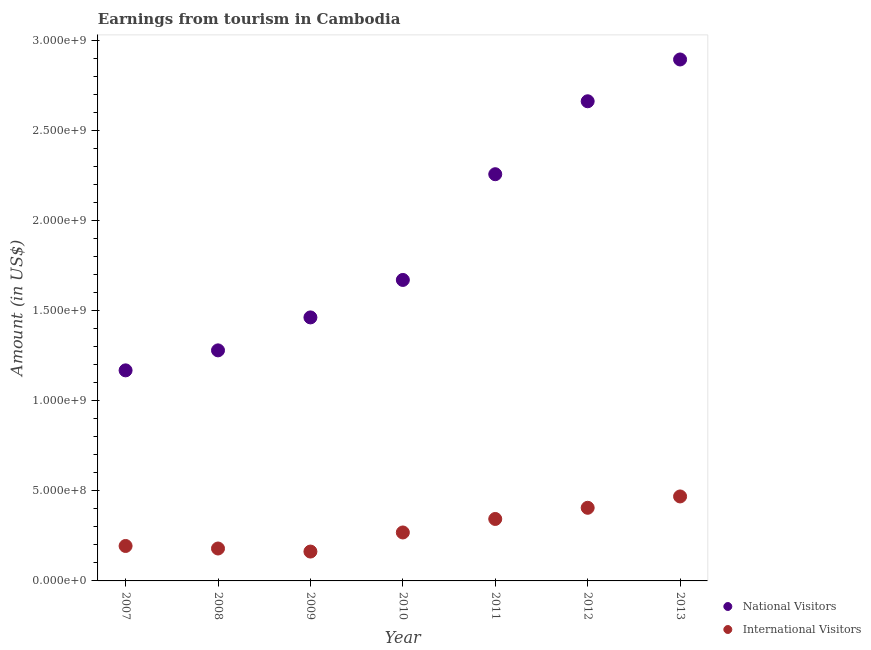How many different coloured dotlines are there?
Your response must be concise. 2. What is the amount earned from international visitors in 2009?
Provide a succinct answer. 1.63e+08. Across all years, what is the maximum amount earned from national visitors?
Give a very brief answer. 2.90e+09. Across all years, what is the minimum amount earned from international visitors?
Provide a succinct answer. 1.63e+08. In which year was the amount earned from international visitors minimum?
Provide a short and direct response. 2009. What is the total amount earned from national visitors in the graph?
Ensure brevity in your answer.  1.34e+1. What is the difference between the amount earned from international visitors in 2007 and that in 2009?
Your answer should be very brief. 3.10e+07. What is the difference between the amount earned from international visitors in 2013 and the amount earned from national visitors in 2009?
Provide a succinct answer. -9.94e+08. What is the average amount earned from international visitors per year?
Keep it short and to the point. 2.89e+08. In the year 2009, what is the difference between the amount earned from international visitors and amount earned from national visitors?
Ensure brevity in your answer.  -1.30e+09. In how many years, is the amount earned from international visitors greater than 2500000000 US$?
Provide a succinct answer. 0. What is the ratio of the amount earned from international visitors in 2009 to that in 2012?
Keep it short and to the point. 0.4. Is the amount earned from national visitors in 2008 less than that in 2009?
Provide a succinct answer. Yes. What is the difference between the highest and the second highest amount earned from international visitors?
Make the answer very short. 6.30e+07. What is the difference between the highest and the lowest amount earned from national visitors?
Your answer should be very brief. 1.73e+09. In how many years, is the amount earned from national visitors greater than the average amount earned from national visitors taken over all years?
Keep it short and to the point. 3. Are the values on the major ticks of Y-axis written in scientific E-notation?
Offer a terse response. Yes. Does the graph contain any zero values?
Give a very brief answer. No. What is the title of the graph?
Your answer should be very brief. Earnings from tourism in Cambodia. Does "Excluding technical cooperation" appear as one of the legend labels in the graph?
Offer a terse response. No. What is the Amount (in US$) of National Visitors in 2007?
Provide a succinct answer. 1.17e+09. What is the Amount (in US$) of International Visitors in 2007?
Your answer should be compact. 1.94e+08. What is the Amount (in US$) in National Visitors in 2008?
Offer a very short reply. 1.28e+09. What is the Amount (in US$) of International Visitors in 2008?
Give a very brief answer. 1.80e+08. What is the Amount (in US$) of National Visitors in 2009?
Your answer should be very brief. 1.46e+09. What is the Amount (in US$) in International Visitors in 2009?
Keep it short and to the point. 1.63e+08. What is the Amount (in US$) of National Visitors in 2010?
Provide a succinct answer. 1.67e+09. What is the Amount (in US$) in International Visitors in 2010?
Make the answer very short. 2.69e+08. What is the Amount (in US$) of National Visitors in 2011?
Offer a terse response. 2.26e+09. What is the Amount (in US$) in International Visitors in 2011?
Offer a very short reply. 3.44e+08. What is the Amount (in US$) in National Visitors in 2012?
Keep it short and to the point. 2.66e+09. What is the Amount (in US$) of International Visitors in 2012?
Give a very brief answer. 4.06e+08. What is the Amount (in US$) in National Visitors in 2013?
Offer a very short reply. 2.90e+09. What is the Amount (in US$) in International Visitors in 2013?
Keep it short and to the point. 4.69e+08. Across all years, what is the maximum Amount (in US$) of National Visitors?
Provide a succinct answer. 2.90e+09. Across all years, what is the maximum Amount (in US$) in International Visitors?
Give a very brief answer. 4.69e+08. Across all years, what is the minimum Amount (in US$) of National Visitors?
Make the answer very short. 1.17e+09. Across all years, what is the minimum Amount (in US$) of International Visitors?
Keep it short and to the point. 1.63e+08. What is the total Amount (in US$) of National Visitors in the graph?
Make the answer very short. 1.34e+1. What is the total Amount (in US$) in International Visitors in the graph?
Ensure brevity in your answer.  2.02e+09. What is the difference between the Amount (in US$) of National Visitors in 2007 and that in 2008?
Provide a succinct answer. -1.11e+08. What is the difference between the Amount (in US$) in International Visitors in 2007 and that in 2008?
Your response must be concise. 1.40e+07. What is the difference between the Amount (in US$) in National Visitors in 2007 and that in 2009?
Give a very brief answer. -2.94e+08. What is the difference between the Amount (in US$) of International Visitors in 2007 and that in 2009?
Provide a short and direct response. 3.10e+07. What is the difference between the Amount (in US$) in National Visitors in 2007 and that in 2010?
Your answer should be compact. -5.02e+08. What is the difference between the Amount (in US$) in International Visitors in 2007 and that in 2010?
Your answer should be very brief. -7.50e+07. What is the difference between the Amount (in US$) in National Visitors in 2007 and that in 2011?
Provide a short and direct response. -1.09e+09. What is the difference between the Amount (in US$) of International Visitors in 2007 and that in 2011?
Offer a terse response. -1.50e+08. What is the difference between the Amount (in US$) in National Visitors in 2007 and that in 2012?
Your answer should be very brief. -1.49e+09. What is the difference between the Amount (in US$) of International Visitors in 2007 and that in 2012?
Provide a succinct answer. -2.12e+08. What is the difference between the Amount (in US$) of National Visitors in 2007 and that in 2013?
Keep it short and to the point. -1.73e+09. What is the difference between the Amount (in US$) in International Visitors in 2007 and that in 2013?
Keep it short and to the point. -2.75e+08. What is the difference between the Amount (in US$) in National Visitors in 2008 and that in 2009?
Your response must be concise. -1.83e+08. What is the difference between the Amount (in US$) in International Visitors in 2008 and that in 2009?
Offer a very short reply. 1.70e+07. What is the difference between the Amount (in US$) of National Visitors in 2008 and that in 2010?
Provide a succinct answer. -3.91e+08. What is the difference between the Amount (in US$) in International Visitors in 2008 and that in 2010?
Offer a very short reply. -8.90e+07. What is the difference between the Amount (in US$) in National Visitors in 2008 and that in 2011?
Keep it short and to the point. -9.78e+08. What is the difference between the Amount (in US$) of International Visitors in 2008 and that in 2011?
Ensure brevity in your answer.  -1.64e+08. What is the difference between the Amount (in US$) in National Visitors in 2008 and that in 2012?
Your answer should be very brief. -1.38e+09. What is the difference between the Amount (in US$) in International Visitors in 2008 and that in 2012?
Offer a terse response. -2.26e+08. What is the difference between the Amount (in US$) in National Visitors in 2008 and that in 2013?
Offer a very short reply. -1.62e+09. What is the difference between the Amount (in US$) in International Visitors in 2008 and that in 2013?
Offer a terse response. -2.89e+08. What is the difference between the Amount (in US$) in National Visitors in 2009 and that in 2010?
Provide a short and direct response. -2.08e+08. What is the difference between the Amount (in US$) in International Visitors in 2009 and that in 2010?
Ensure brevity in your answer.  -1.06e+08. What is the difference between the Amount (in US$) in National Visitors in 2009 and that in 2011?
Provide a short and direct response. -7.95e+08. What is the difference between the Amount (in US$) in International Visitors in 2009 and that in 2011?
Your answer should be very brief. -1.81e+08. What is the difference between the Amount (in US$) in National Visitors in 2009 and that in 2012?
Offer a terse response. -1.20e+09. What is the difference between the Amount (in US$) of International Visitors in 2009 and that in 2012?
Your answer should be compact. -2.43e+08. What is the difference between the Amount (in US$) in National Visitors in 2009 and that in 2013?
Offer a terse response. -1.43e+09. What is the difference between the Amount (in US$) in International Visitors in 2009 and that in 2013?
Provide a succinct answer. -3.06e+08. What is the difference between the Amount (in US$) of National Visitors in 2010 and that in 2011?
Offer a terse response. -5.87e+08. What is the difference between the Amount (in US$) of International Visitors in 2010 and that in 2011?
Provide a short and direct response. -7.50e+07. What is the difference between the Amount (in US$) in National Visitors in 2010 and that in 2012?
Your answer should be compact. -9.92e+08. What is the difference between the Amount (in US$) in International Visitors in 2010 and that in 2012?
Ensure brevity in your answer.  -1.37e+08. What is the difference between the Amount (in US$) in National Visitors in 2010 and that in 2013?
Offer a very short reply. -1.22e+09. What is the difference between the Amount (in US$) in International Visitors in 2010 and that in 2013?
Give a very brief answer. -2.00e+08. What is the difference between the Amount (in US$) of National Visitors in 2011 and that in 2012?
Your answer should be compact. -4.05e+08. What is the difference between the Amount (in US$) of International Visitors in 2011 and that in 2012?
Give a very brief answer. -6.20e+07. What is the difference between the Amount (in US$) of National Visitors in 2011 and that in 2013?
Make the answer very short. -6.37e+08. What is the difference between the Amount (in US$) in International Visitors in 2011 and that in 2013?
Ensure brevity in your answer.  -1.25e+08. What is the difference between the Amount (in US$) in National Visitors in 2012 and that in 2013?
Your answer should be compact. -2.32e+08. What is the difference between the Amount (in US$) of International Visitors in 2012 and that in 2013?
Your answer should be compact. -6.30e+07. What is the difference between the Amount (in US$) of National Visitors in 2007 and the Amount (in US$) of International Visitors in 2008?
Make the answer very short. 9.89e+08. What is the difference between the Amount (in US$) of National Visitors in 2007 and the Amount (in US$) of International Visitors in 2009?
Offer a very short reply. 1.01e+09. What is the difference between the Amount (in US$) in National Visitors in 2007 and the Amount (in US$) in International Visitors in 2010?
Give a very brief answer. 9.00e+08. What is the difference between the Amount (in US$) of National Visitors in 2007 and the Amount (in US$) of International Visitors in 2011?
Your answer should be compact. 8.25e+08. What is the difference between the Amount (in US$) in National Visitors in 2007 and the Amount (in US$) in International Visitors in 2012?
Provide a succinct answer. 7.63e+08. What is the difference between the Amount (in US$) in National Visitors in 2007 and the Amount (in US$) in International Visitors in 2013?
Ensure brevity in your answer.  7.00e+08. What is the difference between the Amount (in US$) of National Visitors in 2008 and the Amount (in US$) of International Visitors in 2009?
Offer a terse response. 1.12e+09. What is the difference between the Amount (in US$) in National Visitors in 2008 and the Amount (in US$) in International Visitors in 2010?
Provide a short and direct response. 1.01e+09. What is the difference between the Amount (in US$) of National Visitors in 2008 and the Amount (in US$) of International Visitors in 2011?
Give a very brief answer. 9.36e+08. What is the difference between the Amount (in US$) of National Visitors in 2008 and the Amount (in US$) of International Visitors in 2012?
Make the answer very short. 8.74e+08. What is the difference between the Amount (in US$) of National Visitors in 2008 and the Amount (in US$) of International Visitors in 2013?
Provide a succinct answer. 8.11e+08. What is the difference between the Amount (in US$) of National Visitors in 2009 and the Amount (in US$) of International Visitors in 2010?
Provide a succinct answer. 1.19e+09. What is the difference between the Amount (in US$) in National Visitors in 2009 and the Amount (in US$) in International Visitors in 2011?
Provide a succinct answer. 1.12e+09. What is the difference between the Amount (in US$) of National Visitors in 2009 and the Amount (in US$) of International Visitors in 2012?
Your answer should be very brief. 1.06e+09. What is the difference between the Amount (in US$) in National Visitors in 2009 and the Amount (in US$) in International Visitors in 2013?
Your response must be concise. 9.94e+08. What is the difference between the Amount (in US$) in National Visitors in 2010 and the Amount (in US$) in International Visitors in 2011?
Your answer should be compact. 1.33e+09. What is the difference between the Amount (in US$) of National Visitors in 2010 and the Amount (in US$) of International Visitors in 2012?
Offer a very short reply. 1.26e+09. What is the difference between the Amount (in US$) in National Visitors in 2010 and the Amount (in US$) in International Visitors in 2013?
Your answer should be compact. 1.20e+09. What is the difference between the Amount (in US$) in National Visitors in 2011 and the Amount (in US$) in International Visitors in 2012?
Your answer should be very brief. 1.85e+09. What is the difference between the Amount (in US$) of National Visitors in 2011 and the Amount (in US$) of International Visitors in 2013?
Offer a very short reply. 1.79e+09. What is the difference between the Amount (in US$) of National Visitors in 2012 and the Amount (in US$) of International Visitors in 2013?
Make the answer very short. 2.19e+09. What is the average Amount (in US$) of National Visitors per year?
Keep it short and to the point. 1.91e+09. What is the average Amount (in US$) in International Visitors per year?
Provide a short and direct response. 2.89e+08. In the year 2007, what is the difference between the Amount (in US$) of National Visitors and Amount (in US$) of International Visitors?
Offer a very short reply. 9.75e+08. In the year 2008, what is the difference between the Amount (in US$) in National Visitors and Amount (in US$) in International Visitors?
Offer a terse response. 1.10e+09. In the year 2009, what is the difference between the Amount (in US$) in National Visitors and Amount (in US$) in International Visitors?
Your answer should be compact. 1.30e+09. In the year 2010, what is the difference between the Amount (in US$) in National Visitors and Amount (in US$) in International Visitors?
Provide a short and direct response. 1.40e+09. In the year 2011, what is the difference between the Amount (in US$) of National Visitors and Amount (in US$) of International Visitors?
Ensure brevity in your answer.  1.91e+09. In the year 2012, what is the difference between the Amount (in US$) in National Visitors and Amount (in US$) in International Visitors?
Provide a succinct answer. 2.26e+09. In the year 2013, what is the difference between the Amount (in US$) of National Visitors and Amount (in US$) of International Visitors?
Make the answer very short. 2.43e+09. What is the ratio of the Amount (in US$) of National Visitors in 2007 to that in 2008?
Your answer should be compact. 0.91. What is the ratio of the Amount (in US$) of International Visitors in 2007 to that in 2008?
Give a very brief answer. 1.08. What is the ratio of the Amount (in US$) of National Visitors in 2007 to that in 2009?
Give a very brief answer. 0.8. What is the ratio of the Amount (in US$) of International Visitors in 2007 to that in 2009?
Your response must be concise. 1.19. What is the ratio of the Amount (in US$) of National Visitors in 2007 to that in 2010?
Provide a succinct answer. 0.7. What is the ratio of the Amount (in US$) in International Visitors in 2007 to that in 2010?
Your response must be concise. 0.72. What is the ratio of the Amount (in US$) in National Visitors in 2007 to that in 2011?
Give a very brief answer. 0.52. What is the ratio of the Amount (in US$) in International Visitors in 2007 to that in 2011?
Ensure brevity in your answer.  0.56. What is the ratio of the Amount (in US$) in National Visitors in 2007 to that in 2012?
Your answer should be very brief. 0.44. What is the ratio of the Amount (in US$) of International Visitors in 2007 to that in 2012?
Your answer should be very brief. 0.48. What is the ratio of the Amount (in US$) of National Visitors in 2007 to that in 2013?
Offer a terse response. 0.4. What is the ratio of the Amount (in US$) in International Visitors in 2007 to that in 2013?
Your answer should be very brief. 0.41. What is the ratio of the Amount (in US$) of National Visitors in 2008 to that in 2009?
Give a very brief answer. 0.87. What is the ratio of the Amount (in US$) in International Visitors in 2008 to that in 2009?
Offer a very short reply. 1.1. What is the ratio of the Amount (in US$) of National Visitors in 2008 to that in 2010?
Make the answer very short. 0.77. What is the ratio of the Amount (in US$) in International Visitors in 2008 to that in 2010?
Give a very brief answer. 0.67. What is the ratio of the Amount (in US$) of National Visitors in 2008 to that in 2011?
Ensure brevity in your answer.  0.57. What is the ratio of the Amount (in US$) of International Visitors in 2008 to that in 2011?
Ensure brevity in your answer.  0.52. What is the ratio of the Amount (in US$) in National Visitors in 2008 to that in 2012?
Your answer should be compact. 0.48. What is the ratio of the Amount (in US$) in International Visitors in 2008 to that in 2012?
Give a very brief answer. 0.44. What is the ratio of the Amount (in US$) of National Visitors in 2008 to that in 2013?
Provide a succinct answer. 0.44. What is the ratio of the Amount (in US$) in International Visitors in 2008 to that in 2013?
Offer a very short reply. 0.38. What is the ratio of the Amount (in US$) of National Visitors in 2009 to that in 2010?
Ensure brevity in your answer.  0.88. What is the ratio of the Amount (in US$) in International Visitors in 2009 to that in 2010?
Ensure brevity in your answer.  0.61. What is the ratio of the Amount (in US$) in National Visitors in 2009 to that in 2011?
Offer a very short reply. 0.65. What is the ratio of the Amount (in US$) in International Visitors in 2009 to that in 2011?
Ensure brevity in your answer.  0.47. What is the ratio of the Amount (in US$) of National Visitors in 2009 to that in 2012?
Offer a terse response. 0.55. What is the ratio of the Amount (in US$) of International Visitors in 2009 to that in 2012?
Provide a succinct answer. 0.4. What is the ratio of the Amount (in US$) of National Visitors in 2009 to that in 2013?
Your response must be concise. 0.51. What is the ratio of the Amount (in US$) in International Visitors in 2009 to that in 2013?
Keep it short and to the point. 0.35. What is the ratio of the Amount (in US$) in National Visitors in 2010 to that in 2011?
Provide a succinct answer. 0.74. What is the ratio of the Amount (in US$) of International Visitors in 2010 to that in 2011?
Offer a terse response. 0.78. What is the ratio of the Amount (in US$) in National Visitors in 2010 to that in 2012?
Provide a succinct answer. 0.63. What is the ratio of the Amount (in US$) in International Visitors in 2010 to that in 2012?
Provide a short and direct response. 0.66. What is the ratio of the Amount (in US$) in National Visitors in 2010 to that in 2013?
Give a very brief answer. 0.58. What is the ratio of the Amount (in US$) of International Visitors in 2010 to that in 2013?
Make the answer very short. 0.57. What is the ratio of the Amount (in US$) in National Visitors in 2011 to that in 2012?
Provide a short and direct response. 0.85. What is the ratio of the Amount (in US$) of International Visitors in 2011 to that in 2012?
Make the answer very short. 0.85. What is the ratio of the Amount (in US$) in National Visitors in 2011 to that in 2013?
Ensure brevity in your answer.  0.78. What is the ratio of the Amount (in US$) in International Visitors in 2011 to that in 2013?
Provide a short and direct response. 0.73. What is the ratio of the Amount (in US$) in National Visitors in 2012 to that in 2013?
Give a very brief answer. 0.92. What is the ratio of the Amount (in US$) in International Visitors in 2012 to that in 2013?
Your answer should be very brief. 0.87. What is the difference between the highest and the second highest Amount (in US$) of National Visitors?
Offer a terse response. 2.32e+08. What is the difference between the highest and the second highest Amount (in US$) of International Visitors?
Offer a very short reply. 6.30e+07. What is the difference between the highest and the lowest Amount (in US$) in National Visitors?
Offer a very short reply. 1.73e+09. What is the difference between the highest and the lowest Amount (in US$) in International Visitors?
Provide a short and direct response. 3.06e+08. 